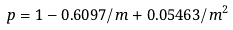Convert formula to latex. <formula><loc_0><loc_0><loc_500><loc_500>p = 1 - 0 . 6 0 9 7 / m + 0 . 0 5 4 6 3 / m ^ { 2 }</formula> 